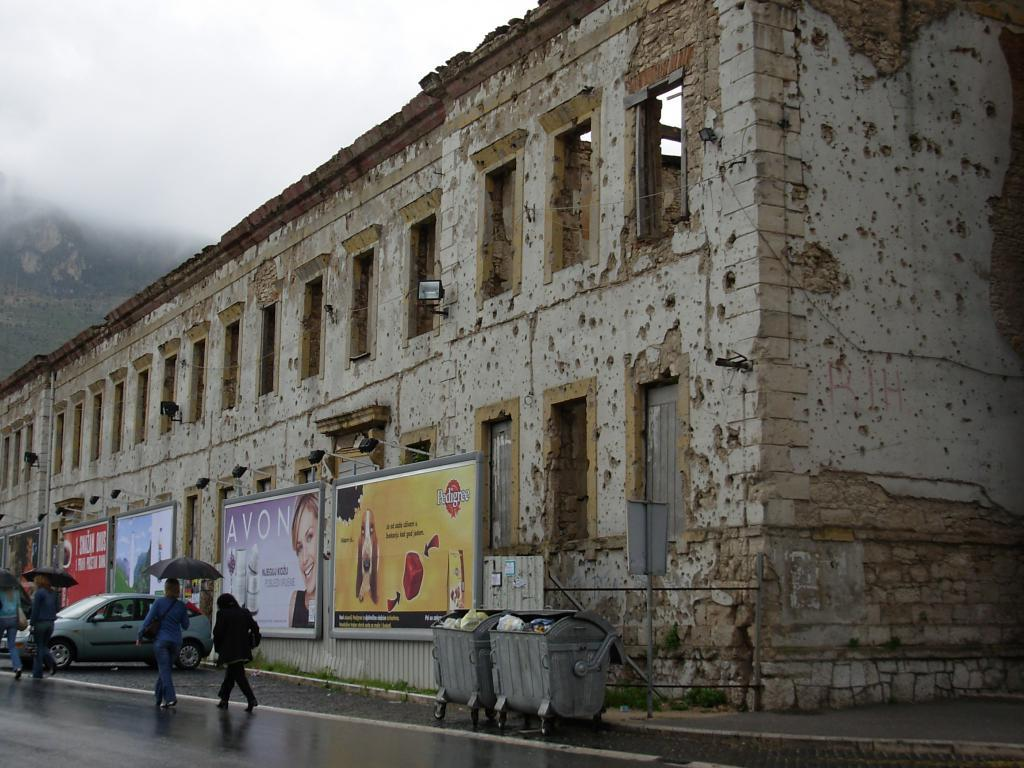<image>
Provide a brief description of the given image. An abandoned building with advertisements for Avon and Pedigree on it. 